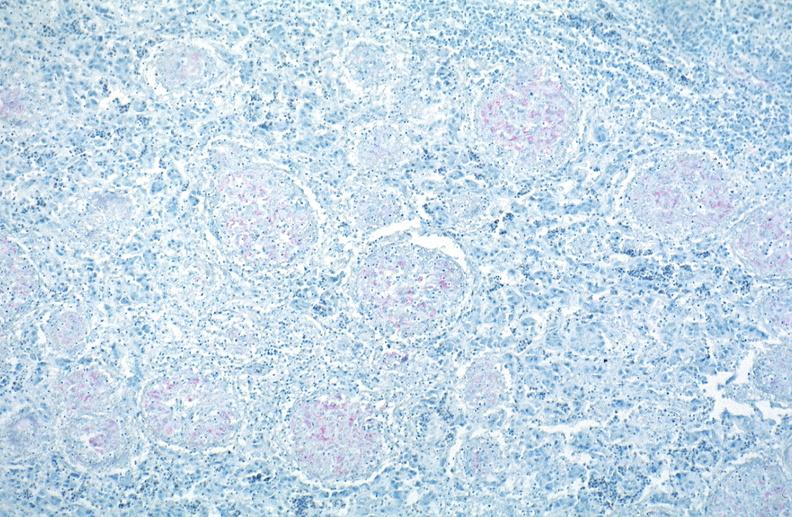where is this?
Answer the question using a single word or phrase. Lung 